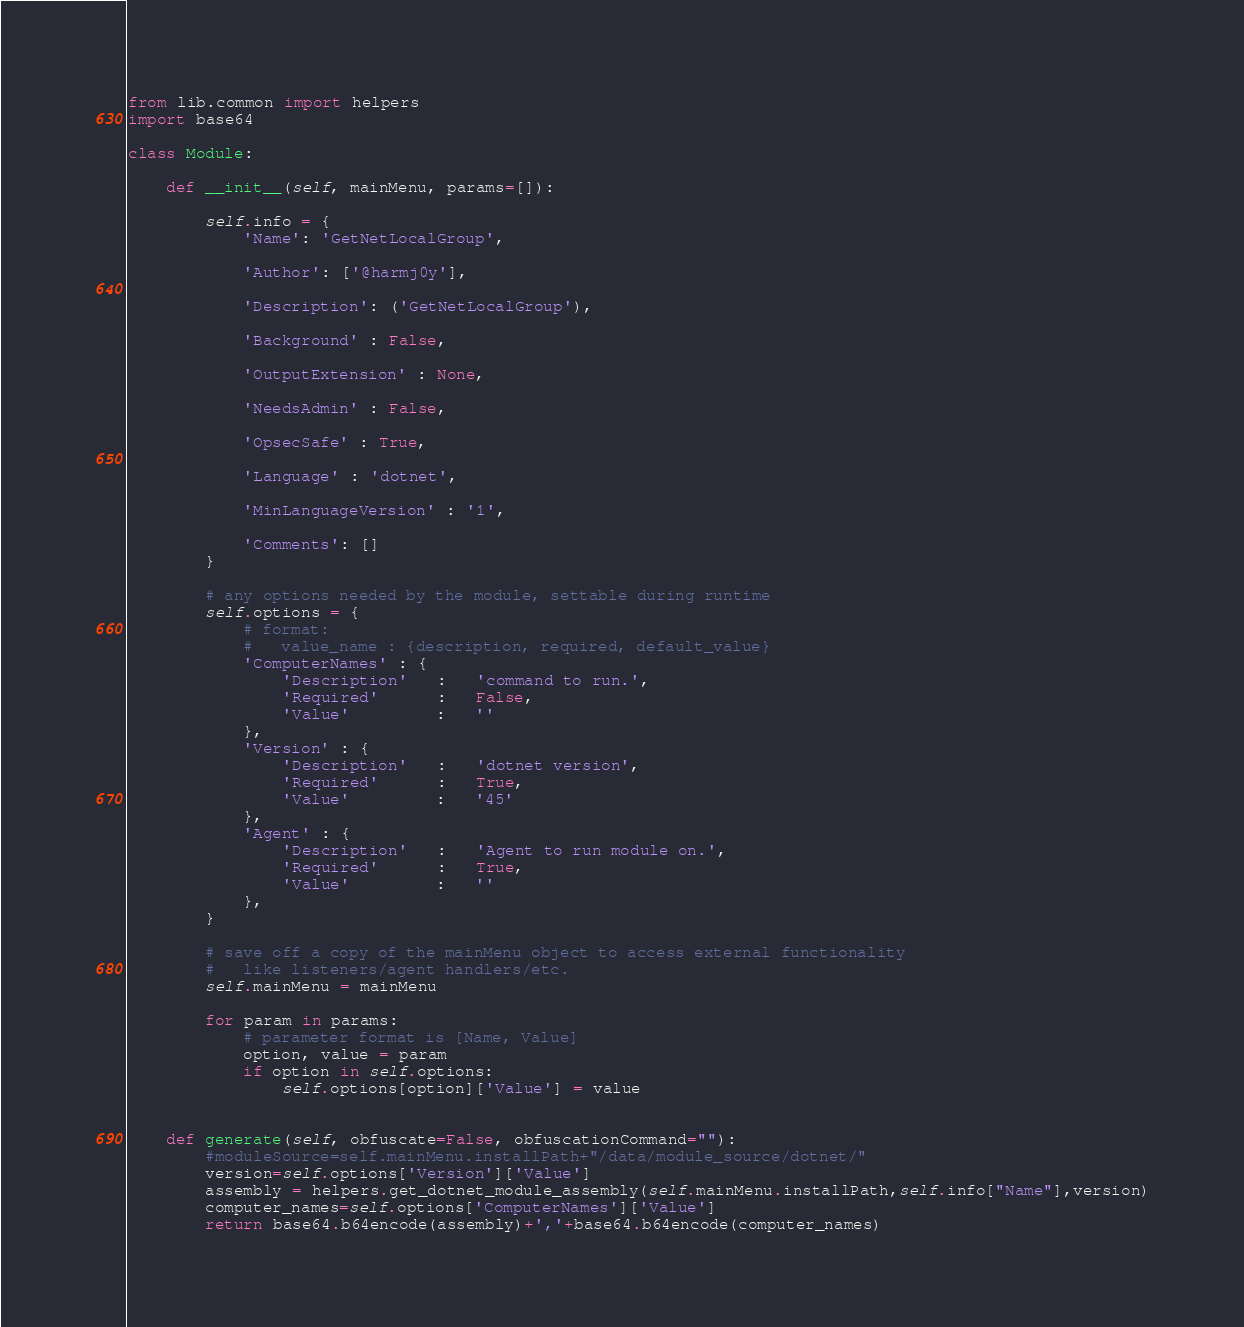Convert code to text. <code><loc_0><loc_0><loc_500><loc_500><_Python_>from lib.common import helpers
import base64

class Module:

    def __init__(self, mainMenu, params=[]):

        self.info = {
            'Name': 'GetNetLocalGroup',

            'Author': ['@harmj0y'],

            'Description': ('GetNetLocalGroup'),

            'Background' : False,

            'OutputExtension' : None,
            
            'NeedsAdmin' : False,

            'OpsecSafe' : True,

            'Language' : 'dotnet',

            'MinLanguageVersion' : '1',
            
            'Comments': []
        }

        # any options needed by the module, settable during runtime
        self.options = {
            # format:
            #   value_name : {description, required, default_value}
            'ComputerNames' : {
                'Description'   :   'command to run.',
                'Required'      :   False,
                'Value'         :   ''
            },
            'Version' : {
                'Description'   :   'dotnet version',
                'Required'      :   True,
                'Value'         :   '45'
            },
            'Agent' : {
                'Description'   :   'Agent to run module on.',
                'Required'      :   True,
                'Value'         :   ''
            },
        }

        # save off a copy of the mainMenu object to access external functionality
        #   like listeners/agent handlers/etc.
        self.mainMenu = mainMenu

        for param in params:
            # parameter format is [Name, Value]
            option, value = param
            if option in self.options:
                self.options[option]['Value'] = value


    def generate(self, obfuscate=False, obfuscationCommand=""):
        #moduleSource=self.mainMenu.installPath+"/data/module_source/dotnet/"
        version=self.options['Version']['Value']
        assembly = helpers.get_dotnet_module_assembly(self.mainMenu.installPath,self.info["Name"],version)
        computer_names=self.options['ComputerNames']['Value']
        return base64.b64encode(assembly)+','+base64.b64encode(computer_names)
</code> 